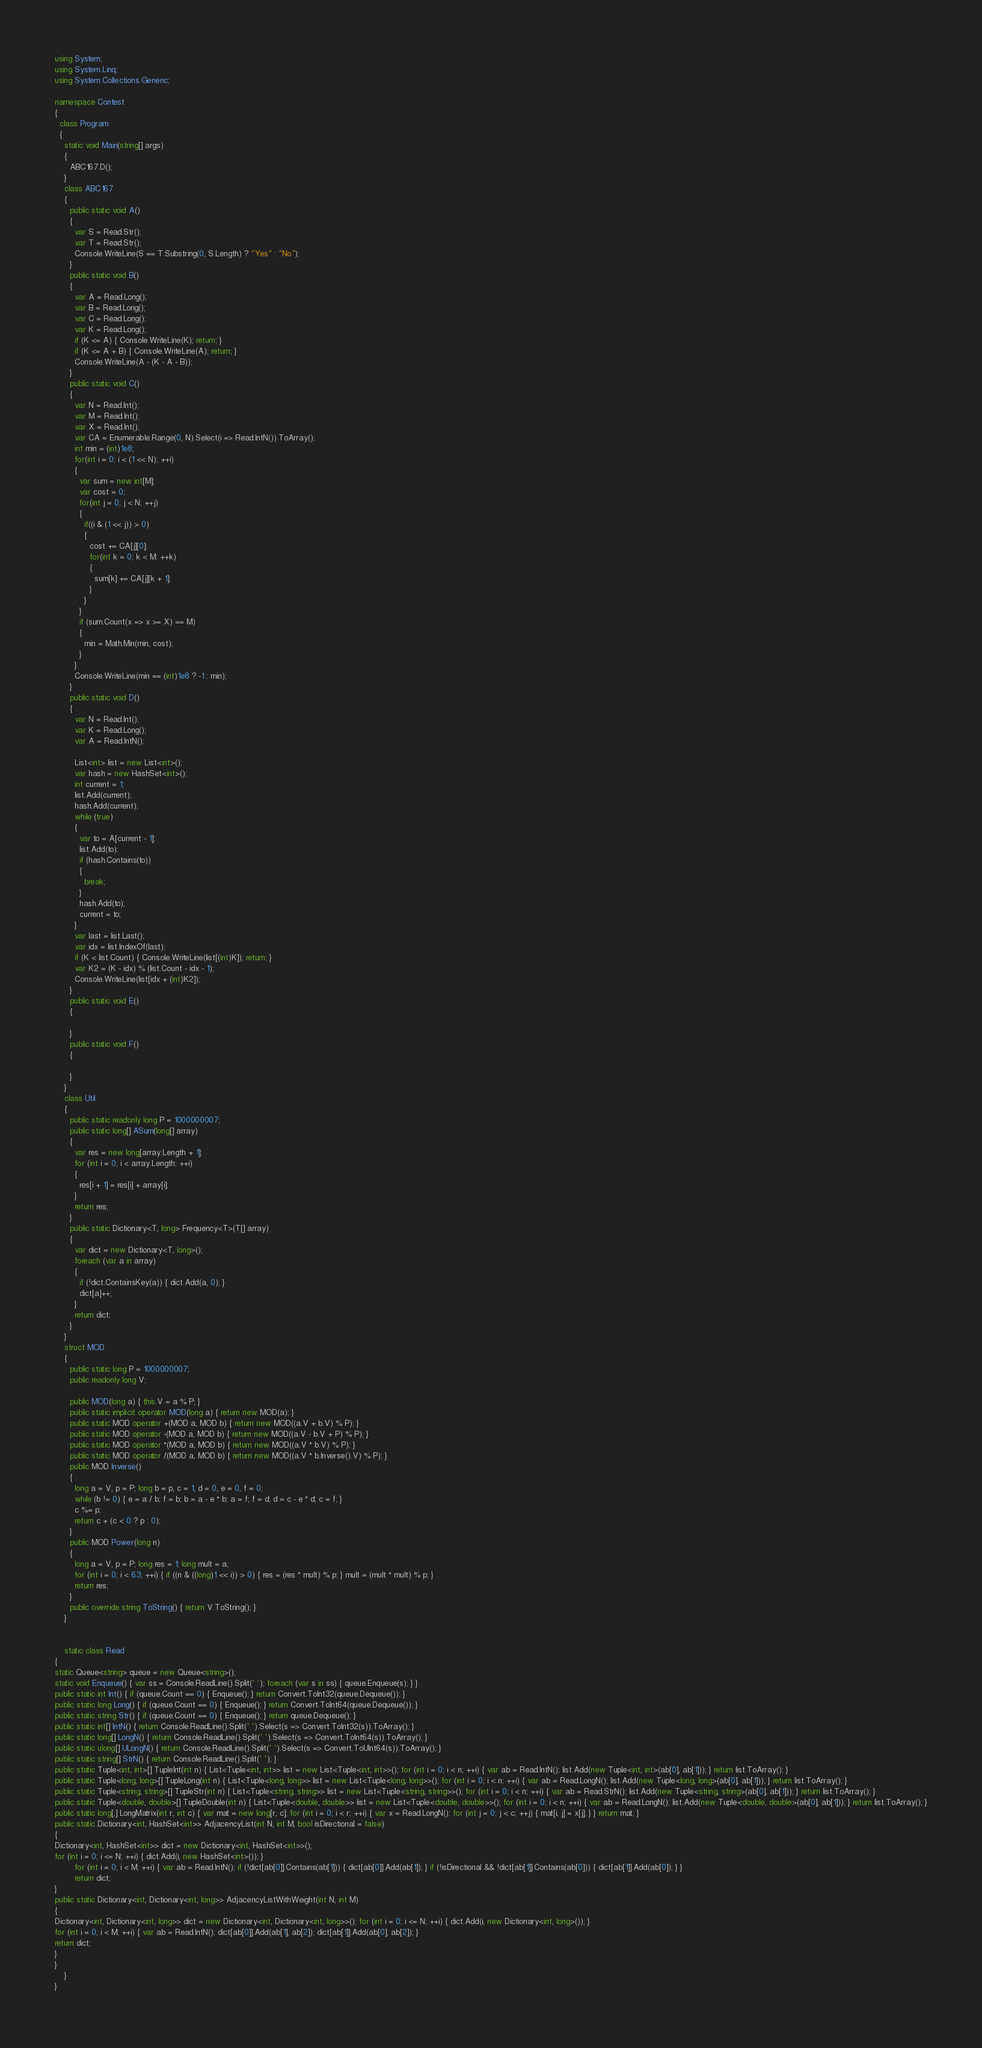Convert code to text. <code><loc_0><loc_0><loc_500><loc_500><_C#_>using System;
using System.Linq;
using System.Collections.Generic;

namespace Contest
{
  class Program
  {
    static void Main(string[] args)
    {
      ABC167.D();
    }
    class ABC167
    {
      public static void A()
      {
        var S = Read.Str();
        var T = Read.Str();
        Console.WriteLine(S == T.Substring(0, S.Length) ? "Yes" : "No");
      }
      public static void B()
      {
        var A = Read.Long();
        var B = Read.Long();
        var C = Read.Long();
        var K = Read.Long();
        if (K <= A) { Console.WriteLine(K); return; }
        if (K <= A + B) { Console.WriteLine(A); return; }
        Console.WriteLine(A - (K - A - B));
      }
      public static void C()
      {
        var N = Read.Int();
        var M = Read.Int();
        var X = Read.Int();
        var CA = Enumerable.Range(0, N).Select(i => Read.IntN()).ToArray();
        int min = (int)1e8;
        for(int i = 0; i < (1 << N); ++i)
        {
          var sum = new int[M];
          var cost = 0;
          for(int j = 0; j < N; ++j)
          {
            if((i & (1 << j)) > 0)
            {
              cost += CA[j][0];
              for(int k = 0; k < M; ++k)
              {
                sum[k] += CA[j][k + 1];
              }
            }
          }
          if (sum.Count(x => x >= X) == M)
          {
            min = Math.Min(min, cost);
          }
        }
        Console.WriteLine(min == (int)1e8 ? -1 : min);
      }
      public static void D()
      {
        var N = Read.Int();
        var K = Read.Long();
        var A = Read.IntN();

        List<int> list = new List<int>();
        var hash = new HashSet<int>();
        int current = 1;
        list.Add(current);
        hash.Add(current);
        while (true)
        {
          var to = A[current - 1];
          list.Add(to);
          if (hash.Contains(to))
          {
            break;
          }
          hash.Add(to);
          current = to;
        }
        var last = list.Last();
        var idx = list.IndexOf(last);
        if (K < list.Count) { Console.WriteLine(list[(int)K]); return; }
        var K2 = (K - idx) % (list.Count - idx - 1);
        Console.WriteLine(list[idx + (int)K2]);
      }
      public static void E()
      {

      }
      public static void F()
      {

      }
    }
    class Util
    {
      public static readonly long P = 1000000007;
      public static long[] ASum(long[] array)
      {
        var res = new long[array.Length + 1];
        for (int i = 0; i < array.Length; ++i)
        {
          res[i + 1] = res[i] + array[i];
        }
        return res;
      }
      public static Dictionary<T, long> Frequency<T>(T[] array)
      {
        var dict = new Dictionary<T, long>();
        foreach (var a in array)
        {
          if (!dict.ContainsKey(a)) { dict.Add(a, 0); }
          dict[a]++;
        }
        return dict;
      }
    }
    struct MOD
    {
      public static long P = 1000000007;
      public readonly long V;

      public MOD(long a) { this.V = a % P; }
      public static implicit operator MOD(long a) { return new MOD(a); }
      public static MOD operator +(MOD a, MOD b) { return new MOD((a.V + b.V) % P); }
      public static MOD operator -(MOD a, MOD b) { return new MOD((a.V - b.V + P) % P); }
      public static MOD operator *(MOD a, MOD b) { return new MOD((a.V * b.V) % P); }
      public static MOD operator /(MOD a, MOD b) { return new MOD((a.V * b.Inverse().V) % P); }
      public MOD Inverse()
      {
        long a = V, p = P; long b = p, c = 1, d = 0, e = 0, f = 0;
        while (b != 0) { e = a / b; f = b; b = a - e * b; a = f; f = d; d = c - e * d; c = f; }
        c %= p;
        return c + (c < 0 ? p : 0);
      }
      public MOD Power(long n)
      {
        long a = V, p = P; long res = 1; long mult = a;
        for (int i = 0; i < 63; ++i) { if ((n & ((long)1 << i)) > 0) { res = (res * mult) % p; } mult = (mult * mult) % p; }
        return res;
      }
      public override string ToString() { return V.ToString(); }
    }


    static class Read
{
static Queue<string> queue = new Queue<string>();
static void Enqueue() { var ss = Console.ReadLine().Split(' '); foreach (var s in ss) { queue.Enqueue(s); } }
public static int Int() { if (queue.Count == 0) { Enqueue(); } return Convert.ToInt32(queue.Dequeue()); }
public static long Long() { if (queue.Count == 0) { Enqueue(); } return Convert.ToInt64(queue.Dequeue()); }
public static string Str() { if (queue.Count == 0) { Enqueue(); } return queue.Dequeue(); }
public static int[] IntN() { return Console.ReadLine().Split(' ').Select(s => Convert.ToInt32(s)).ToArray(); }
public static long[] LongN() { return Console.ReadLine().Split(' ').Select(s => Convert.ToInt64(s)).ToArray(); }
public static ulong[] ULongN() { return Console.ReadLine().Split(' ').Select(s => Convert.ToUInt64(s)).ToArray(); }
public static string[] StrN() { return Console.ReadLine().Split(' '); }
public static Tuple<int, int>[] TupleInt(int n) { List<Tuple<int, int>> list = new List<Tuple<int, int>>(); for (int i = 0; i < n; ++i) { var ab = Read.IntN(); list.Add(new Tuple<int, int>(ab[0], ab[1])); } return list.ToArray(); }
public static Tuple<long, long>[] TupleLong(int n) { List<Tuple<long, long>> list = new List<Tuple<long, long>>(); for (int i = 0; i < n; ++i) { var ab = Read.LongN(); list.Add(new Tuple<long, long>(ab[0], ab[1])); } return list.ToArray(); }
public static Tuple<string, string>[] TupleStr(int n) { List<Tuple<string, string>> list = new List<Tuple<string, string>>(); for (int i = 0; i < n; ++i) { var ab = Read.StrN(); list.Add(new Tuple<string, string>(ab[0], ab[1])); } return list.ToArray(); }
public static Tuple<double, double>[] TupleDouble(int n) { List<Tuple<double, double>> list = new List<Tuple<double, double>>(); for (int i = 0; i < n; ++i) { var ab = Read.LongN(); list.Add(new Tuple<double, double>(ab[0], ab[1])); } return list.ToArray(); }
public static long[,] LongMatrix(int r, int c) { var mat = new long[r, c]; for (int i = 0; i < r; ++i) { var x = Read.LongN(); for (int j = 0; j < c; ++j) { mat[i, j] = x[j]; } } return mat; }
public static Dictionary<int, HashSet<int>> AdjacencyList(int N, int M, bool isDirectional = false)
{
Dictionary<int, HashSet<int>> dict = new Dictionary<int, HashSet<int>>();
for (int i = 0; i <= N; ++i) { dict.Add(i, new HashSet<int>()); }
        for (int i = 0; i < M; ++i) { var ab = Read.IntN(); if (!dict[ab[0]].Contains(ab[1])) { dict[ab[0]].Add(ab[1]); } if (!isDirectional && !dict[ab[1]].Contains(ab[0])) { dict[ab[1]].Add(ab[0]); } }
        return dict;
}
public static Dictionary<int, Dictionary<int, long>> AdjacencyListWithWeight(int N, int M)
{
Dictionary<int, Dictionary<int, long>> dict = new Dictionary<int, Dictionary<int, long>>(); for (int i = 0; i <= N; ++i) { dict.Add(i, new Dictionary<int, long>()); }
for (int i = 0; i < M; ++i) { var ab = Read.IntN(); dict[ab[0]].Add(ab[1], ab[2]); dict[ab[1]].Add(ab[0], ab[2]); }
return dict;
}
}
    }
}
</code> 